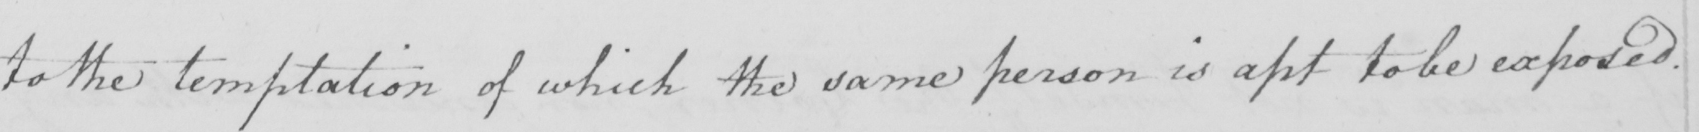Can you tell me what this handwritten text says? to the temptation of which the same person is apt to be exposed . 